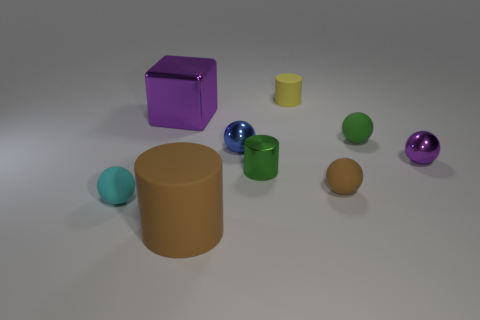How many other objects are the same size as the green matte object?
Give a very brief answer. 6. There is a tiny thing that is the same color as the big cube; what shape is it?
Your response must be concise. Sphere. How many objects are small purple spheres or small matte balls to the left of the brown matte cylinder?
Make the answer very short. 2. Are there more big cyan rubber cylinders than small shiny objects?
Keep it short and to the point. No. What is the shape of the brown rubber object that is right of the big brown rubber cylinder?
Offer a terse response. Sphere. What number of tiny green metallic objects are the same shape as the yellow rubber object?
Your answer should be compact. 1. There is a purple metal object that is right of the object behind the big shiny object; how big is it?
Your response must be concise. Small. How many brown things are either small balls or large shiny cubes?
Your answer should be very brief. 1. Are there fewer tiny matte objects that are in front of the green metal cylinder than brown spheres to the left of the large brown matte thing?
Give a very brief answer. No. Do the blue shiny ball and the purple metallic object that is on the left side of the green rubber ball have the same size?
Provide a succinct answer. No. 